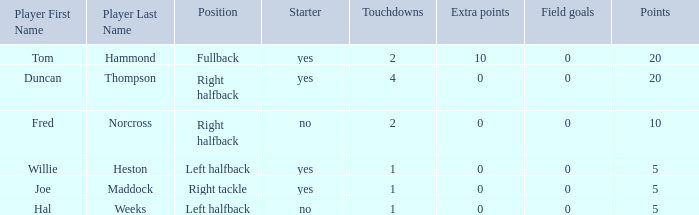How many field goals did duncan thompson have? 0.0. 